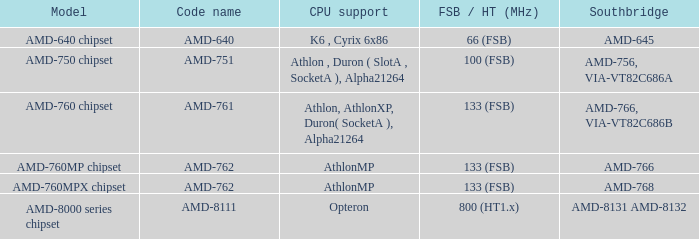What is the FSB / HT (MHz) when the Southbridge is amd-8131 amd-8132? 800 (HT1.x). 